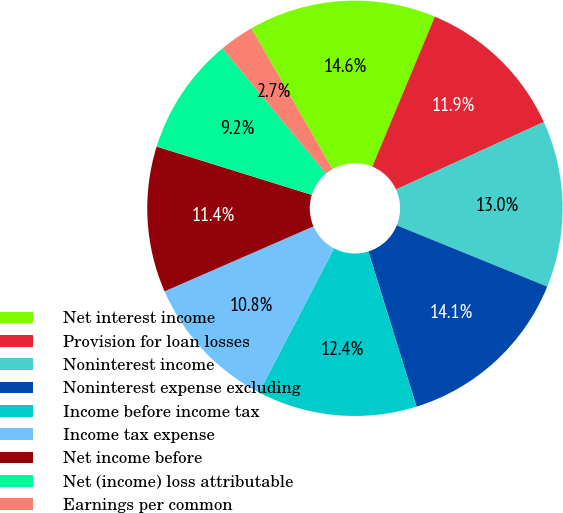<chart> <loc_0><loc_0><loc_500><loc_500><pie_chart><fcel>Net interest income<fcel>Provision for loan losses<fcel>Noninterest income<fcel>Noninterest expense excluding<fcel>Income before income tax<fcel>Income tax expense<fcel>Net income before<fcel>Net (income) loss attributable<fcel>Earnings per common<nl><fcel>14.59%<fcel>11.89%<fcel>12.97%<fcel>14.05%<fcel>12.43%<fcel>10.81%<fcel>11.35%<fcel>9.19%<fcel>2.7%<nl></chart> 